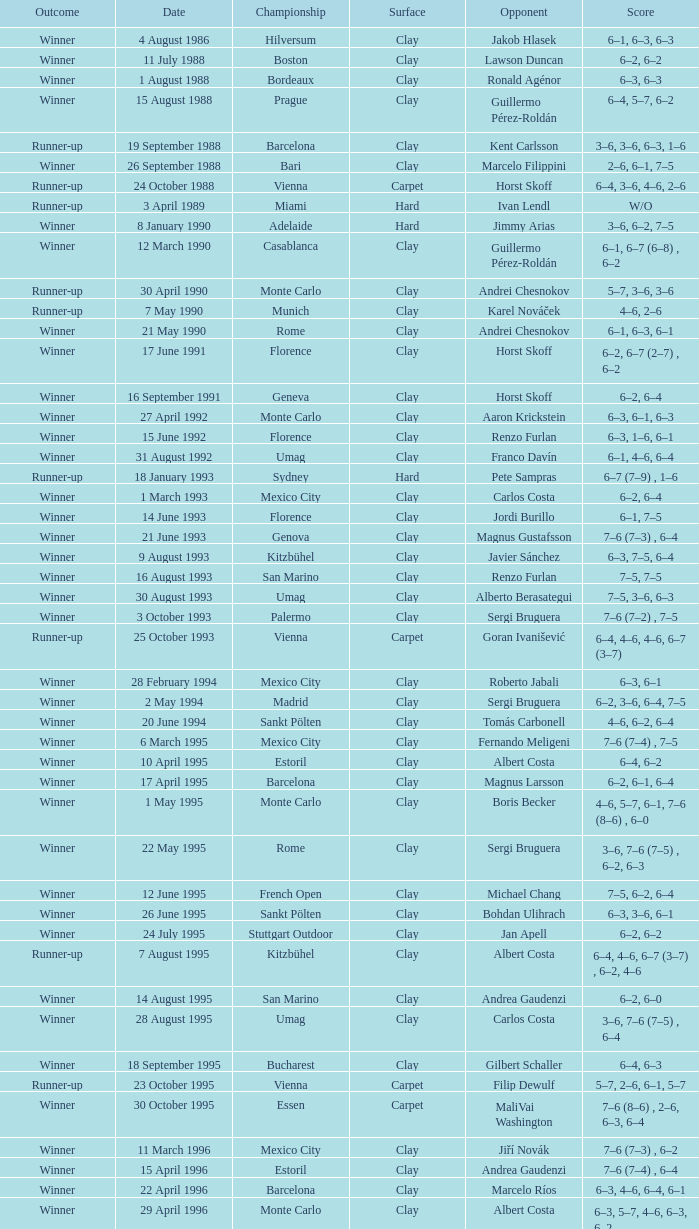In the rome championship, what is the score against opponent richard krajicek? 6–2, 6–4, 3–6, 6–3. 